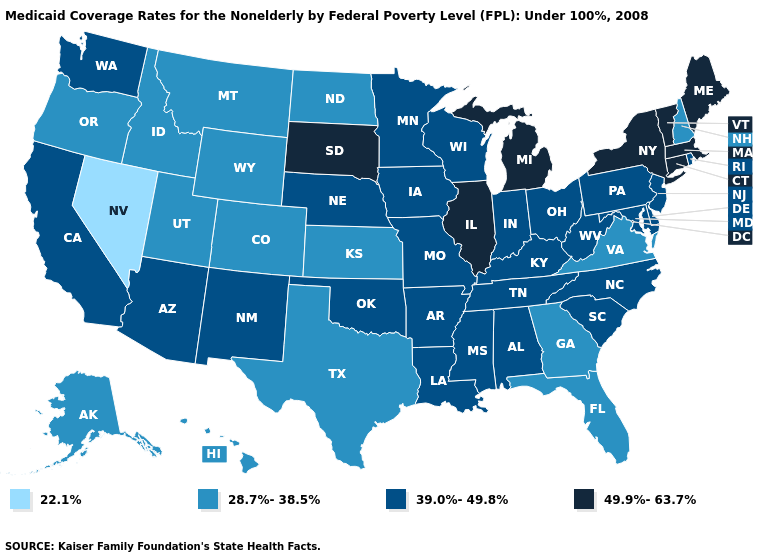Among the states that border Tennessee , which have the lowest value?
Give a very brief answer. Georgia, Virginia. What is the value of Kansas?
Quick response, please. 28.7%-38.5%. Does Nebraska have a lower value than Michigan?
Give a very brief answer. Yes. What is the lowest value in the USA?
Answer briefly. 22.1%. Which states have the lowest value in the USA?
Answer briefly. Nevada. Name the states that have a value in the range 28.7%-38.5%?
Write a very short answer. Alaska, Colorado, Florida, Georgia, Hawaii, Idaho, Kansas, Montana, New Hampshire, North Dakota, Oregon, Texas, Utah, Virginia, Wyoming. Name the states that have a value in the range 22.1%?
Be succinct. Nevada. Is the legend a continuous bar?
Keep it brief. No. What is the highest value in the USA?
Be succinct. 49.9%-63.7%. Name the states that have a value in the range 39.0%-49.8%?
Quick response, please. Alabama, Arizona, Arkansas, California, Delaware, Indiana, Iowa, Kentucky, Louisiana, Maryland, Minnesota, Mississippi, Missouri, Nebraska, New Jersey, New Mexico, North Carolina, Ohio, Oklahoma, Pennsylvania, Rhode Island, South Carolina, Tennessee, Washington, West Virginia, Wisconsin. Among the states that border Montana , does Wyoming have the lowest value?
Answer briefly. Yes. What is the lowest value in the USA?
Give a very brief answer. 22.1%. Does Hawaii have the same value as Louisiana?
Keep it brief. No. What is the value of Missouri?
Keep it brief. 39.0%-49.8%. What is the highest value in the USA?
Be succinct. 49.9%-63.7%. 